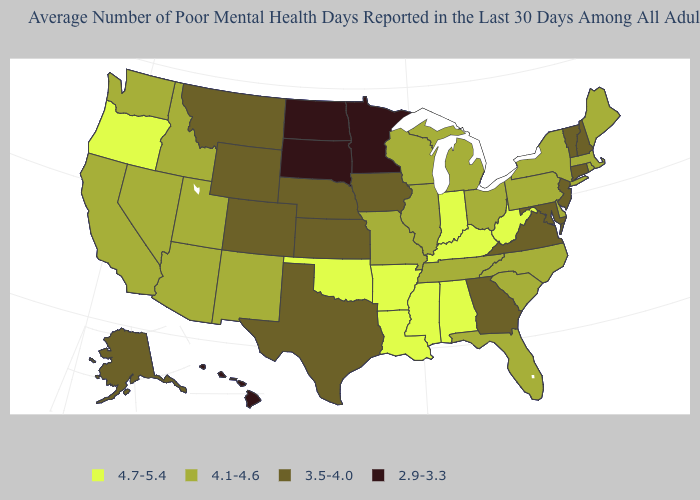What is the value of New York?
Answer briefly. 4.1-4.6. Which states have the lowest value in the MidWest?
Quick response, please. Minnesota, North Dakota, South Dakota. What is the value of Virginia?
Write a very short answer. 3.5-4.0. Among the states that border Delaware , does Pennsylvania have the highest value?
Keep it brief. Yes. Name the states that have a value in the range 4.1-4.6?
Be succinct. Arizona, California, Delaware, Florida, Idaho, Illinois, Maine, Massachusetts, Michigan, Missouri, Nevada, New Mexico, New York, North Carolina, Ohio, Pennsylvania, Rhode Island, South Carolina, Tennessee, Utah, Washington, Wisconsin. How many symbols are there in the legend?
Keep it brief. 4. What is the highest value in states that border Texas?
Quick response, please. 4.7-5.4. Does Rhode Island have the highest value in the Northeast?
Give a very brief answer. Yes. What is the lowest value in states that border Tennessee?
Short answer required. 3.5-4.0. What is the highest value in states that border New Mexico?
Write a very short answer. 4.7-5.4. Among the states that border Maryland , does Virginia have the highest value?
Concise answer only. No. Among the states that border Maryland , does Pennsylvania have the highest value?
Give a very brief answer. No. What is the lowest value in the West?
Be succinct. 2.9-3.3. Name the states that have a value in the range 2.9-3.3?
Concise answer only. Hawaii, Minnesota, North Dakota, South Dakota. Does Mississippi have the same value as Oklahoma?
Write a very short answer. Yes. 